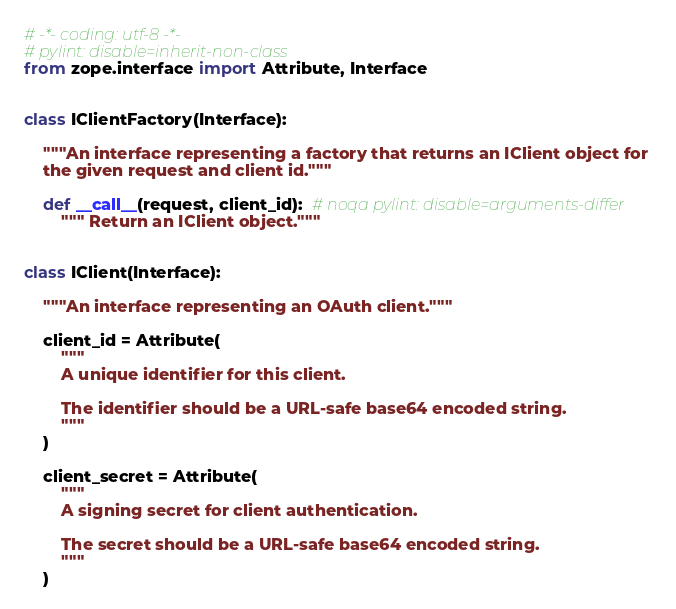<code> <loc_0><loc_0><loc_500><loc_500><_Python_># -*- coding: utf-8 -*-
# pylint: disable=inherit-non-class
from zope.interface import Attribute, Interface


class IClientFactory(Interface):

    """An interface representing a factory that returns an IClient object for
    the given request and client id."""

    def __call__(request, client_id):  # noqa pylint: disable=arguments-differ
        """ Return an IClient object."""


class IClient(Interface):

    """An interface representing an OAuth client."""

    client_id = Attribute(
        """
        A unique identifier for this client.

        The identifier should be a URL-safe base64 encoded string.
        """
    )

    client_secret = Attribute(
        """
        A signing secret for client authentication.

        The secret should be a URL-safe base64 encoded string.
        """
    )
</code> 